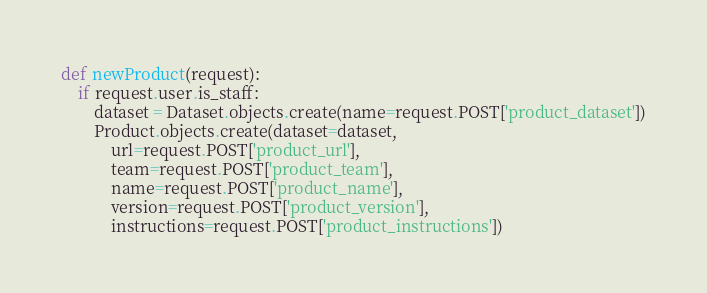<code> <loc_0><loc_0><loc_500><loc_500><_Python_>
def newProduct(request):
    if request.user.is_staff:
        dataset = Dataset.objects.create(name=request.POST['product_dataset'])
        Product.objects.create(dataset=dataset,
            url=request.POST['product_url'],
            team=request.POST['product_team'],
            name=request.POST['product_name'],
            version=request.POST['product_version'],
            instructions=request.POST['product_instructions'])</code> 